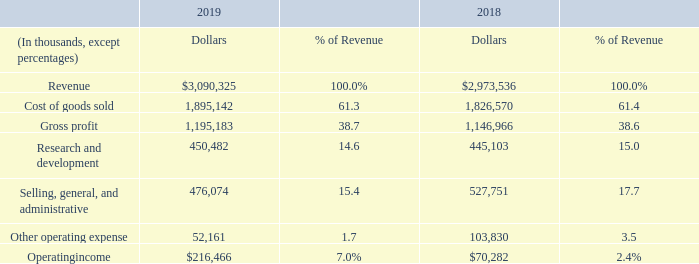Consolidated
The table below presents a summary of our results of operations for fiscal years 2019 and 2018. See Part II, Item 7 of our Annual Report on Form 10-K for the fiscal year ended March 31, 2018, filed with the SEC on May 21, 2018, for Management’s Discussions and Analysis of Financial Condition and Results of Operations for the fiscal year ended April 1, 2017.
REVENUE
Our overall revenue increased $116.8 million in fiscal 2019, compared to fiscal 2018, primarily due to higher demand for our mobile products in support of customers based in China as well as higher demand for our base station products, partially offset by a decrease in revenue due to weakness in marquee smartphone demand experienced by our largest end customer.
We provided our products to our largest end customer (Apple) through sales to multiple contract manufacturers, which in the aggregate accounted for 32% and 36% of total revenue in fiscal years 2019 and 2018, respectively. Huawei accounted for approximately 13% and 8% of our total revenue in fiscal years 2019 and 2018, respectively. These customers primarily purchase RF and Wi-Fi solutions for cellular base stations and a variety of mobile devices, including smartphones, wearables, laptops, tablets and cellular-based applications for the IoT. In May 2019, the U.S. government imposed restrictions on the sales of products to Huawei (see Note 2 of the Notes to the Consolidated Financial Statements set forth in Part II, Item 8 of this report).
International shipments amounted to $2,610.0 million in fiscal 2019 (approximately 84% of revenue) compared to $2,449.1 million in fiscal 2018 (approximately 82% of revenue). Shipments to Asia totaled $2,446.3 million in fiscal 2019 (approximately 79% of revenue) compared to $2,329.3 million in fiscal 2018 (approximately 78% of revenue).
GROSS MARGIN
Gross margin was relatively flat for fiscal 2019 as compared to fiscal 2018, with average selling price erosion offset by favorable changes in product mix.
OPERATING EXPENSES
Research and Development
In fiscal 2019, R&D spending increased $5.4 million, compared to fiscal 2018, primarily due to higher personnel related costs, partially offset by lower product development spend driven by R&D efficiency initiatives.
Selling, General and Administrative
In fiscal 2019, selling, general and administrative expense decreased $51.7 million, or 9.8%, compared to fiscal 2018, primarily due to lower intangible amortization, partially offset by higher personnel related costs.
Other Operating Expense
In fiscal 2019, other operating expense was $52.2 million. In fiscal 2019, we recognized $15.9 million of asset impairment charges (to adjust the carrying value of certain property and equipment to reflect fair value) and $11.6 million of employee termination benefits as a result of restructuring actions (see Note 11 of the Notes to the Consolidated Financial Statements set forth in Part II, Item 8 of this report for information on restructuring actions). In fiscal 2019, we also recorded $18.0 million of start-up costs related to new processes and operations in existing facilities.
In fiscal 2018, other operating expense was $103.8 million. In fiscal 2018, we initiated restructuring actions to improve operating efficiencies, and, as a result of these actions, we recorded approximately $18.3 million of employee termination benefits and adjusted the carrying value of certain held for sale assets located in China and the U.S. to fair market value (resulting in impairment charges totaling approximately $46.3 million). In fiscal 2018, we also recorded integration costs and restructuring costs of $6.2 million and $2.6 million, respectively, associated with the Business Combination, as well as $24.3 million of start-up costs related to new processes and operations in both existing and new facilities.
OPERATING INCOME
Our overall operating income was $216.5 million for fiscal 2019, compared to $70.3 million for fiscal 2018. This increase was primarily due to lower intangible amortization, higher revenue, and lower impairment charges on property and equipment.
What are the company's respective revenue in 2018 and 2019?
Answer scale should be: thousand. $2,973,536, $3,090,325. What are the company's respective cost of goods sold in 2018 and 2019?
Answer scale should be: thousand. 1,826,570, 1,895,142. What are the company's respective gross profit in 2018 and 2019?
Answer scale should be: thousand. 1,146,966, 1,195,183. What is the company's average revenue in 2018 and 2019?
Answer scale should be: thousand. ($2,973,536 + $3,090,325)/2 
Answer: 3031930.5. What is the company's average cost of goods sold in 2018 and 2019?
Answer scale should be: thousand. (1,826,570 + 1,895,142)/2 
Answer: 1860856. What is the company's average gross profit in 2018 and 2019?
Answer scale should be: thousand. (1,146,966 + 1,195,183)/2 
Answer: 1171074.5. 